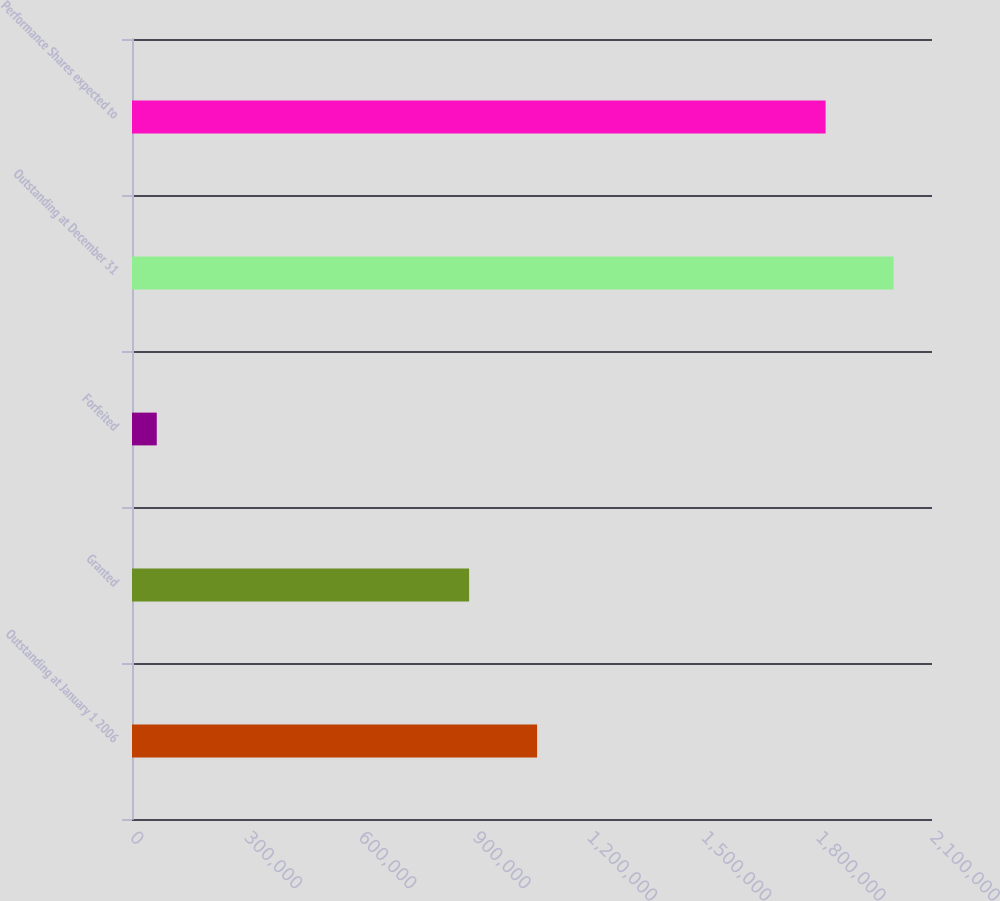Convert chart. <chart><loc_0><loc_0><loc_500><loc_500><bar_chart><fcel>Outstanding at January 1 2006<fcel>Granted<fcel>Forfeited<fcel>Outstanding at December 31<fcel>Performance Shares expected to<nl><fcel>1.06333e+06<fcel>884875<fcel>65000<fcel>1.9992e+06<fcel>1.82074e+06<nl></chart> 